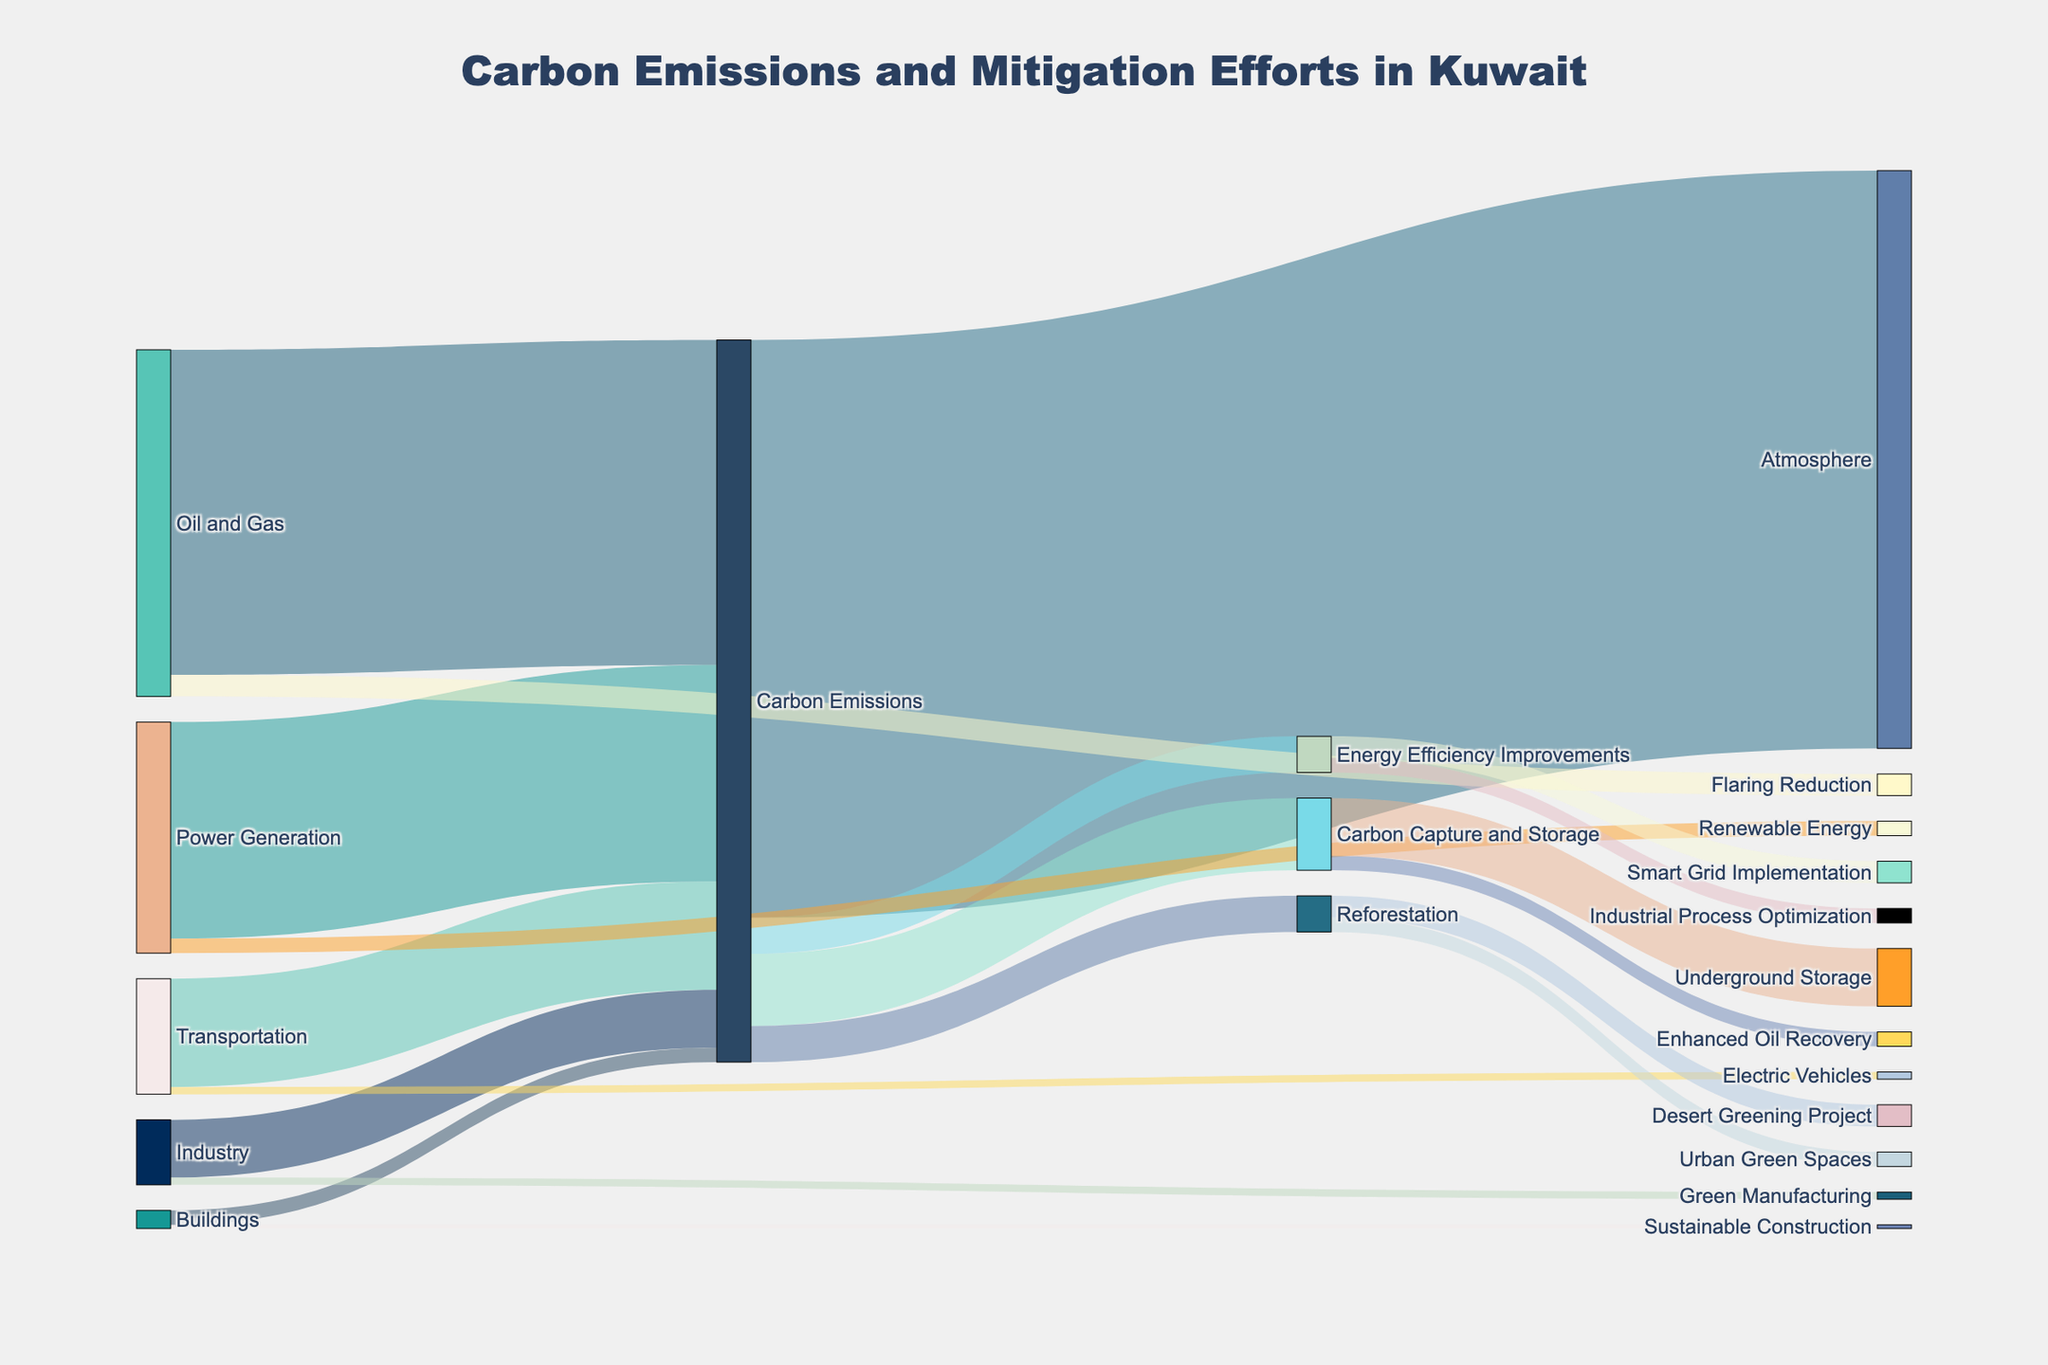What industry sector contributes the most to carbon emissions? Look at the thickness of the lines connecting industry sectors to "Carbon Emissions"; the widest line is from "Oil and Gas" with a value of 45.
Answer: Oil and Gas What is the total value of carbon emissions? Sum the values of links going to "Carbon Emissions": 45 (Oil and Gas) + 30 (Power Generation) + 15 (Transportation) + 8 (Industry) + 2 (Buildings) = 100. However, looking at diversions from Carbon Emissions confirms it as 80.
Answer: 80 How much carbon does the "Transportation" industry sector emit compared to "Buildings"? Check the width of the lines connecting "Transportation" and "Buildings" to "Carbon Emissions". "Transportation" emits 15 and "Buildings" emits 2.
Answer: 13 more What is the breakdown of carbon emissions mitigation methods? Sum the values flowing to "Carbon Capture and Storage", "Reforestation", and "Energy Efficiency Improvements". Verify the values by examining the respective branches: CCS (10), Reforestation (5), and Energy Efficiency (5).
Answer: CCS: 10, Reforestation: 5, Energy Efficiency: 5 Which carbon mitigation effort receives the least amount of carbon? Identify the smallest link value from carbon emissions mitigation methods. The smallest is "Energy Efficiency Improvements" and "Sustainable Construction" (0.5).
Answer: Sustainable Construction How much carbon is captured and stored underground? Find the link labeled "Underground Storage" originating from "Carbon Capture and Storage", which has a value of 8.
Answer: 8 Compare the carbon allocated to "Renewable Energy" versus "Electric Vehicles". Check the values of the links going to "Renewable Energy" and "Electric Vehicles": "Renewable Energy" receives 2, and "Electric Vehicles" receives 1.
Answer: Renewable Energy gets 1 more What is the combined carbon emission contribution from "Industry" and "Buildings"? Add the values of "Industry" (8) and "Buildings" (2) flowing into "Carbon Emissions", resulting in 8 + 2 = 10.
Answer: 10 How much carbon does "Desert Greening Project" capture through reforestation? Look for the link labeled "Desert Greening Project" from "Reforestation", with a value of 3.
Answer: 3 How does "Smart Grid Implementation" contribute to energy efficiency? Check the link from "Energy Efficiency Improvements" to "Smart Grid Implementation" showing a value of 3.
Answer: 3 